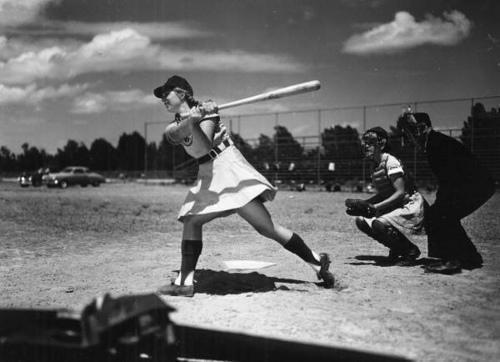How many people are in the picture?
Give a very brief answer. 3. 